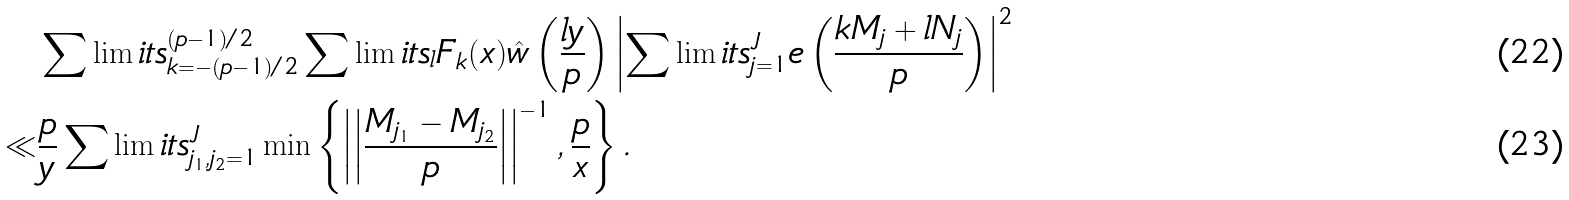Convert formula to latex. <formula><loc_0><loc_0><loc_500><loc_500>& \sum \lim i t s _ { k = - ( p - 1 ) / 2 } ^ { ( p - 1 ) / 2 } \sum \lim i t s _ { l } F _ { k } ( x ) \hat { w } \left ( \frac { l y } { p } \right ) \left | \sum \lim i t s _ { j = 1 } ^ { J } e \left ( \frac { k M _ { j } + l N _ { j } } { p } \right ) \right | ^ { 2 } \\ \ll & \frac { p } { y } \sum \lim i t s _ { j _ { 1 } , j _ { 2 } = 1 } ^ { J } \min \left \{ \left | \left | \frac { M _ { j _ { 1 } } - M _ { j _ { 2 } } } { p } \right | \right | ^ { - 1 } , \frac { p } { x } \right \} .</formula> 